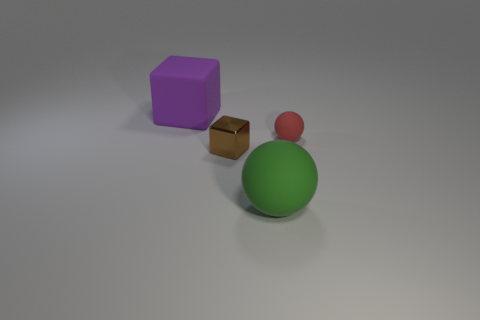Add 4 tiny shiny objects. How many objects exist? 8 Add 3 small matte balls. How many small matte balls are left? 4 Add 4 large red cylinders. How many large red cylinders exist? 4 Subtract 1 red spheres. How many objects are left? 3 Subtract all large brown shiny cylinders. Subtract all small rubber spheres. How many objects are left? 3 